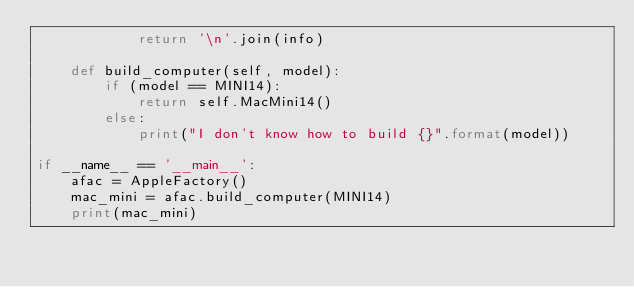Convert code to text. <code><loc_0><loc_0><loc_500><loc_500><_Python_>            return '\n'.join(info)

    def build_computer(self, model):
        if (model == MINI14):
            return self.MacMini14()
        else:
            print("I don't know how to build {}".format(model))

if __name__ == '__main__':
    afac = AppleFactory()
    mac_mini = afac.build_computer(MINI14)
    print(mac_mini)
</code> 